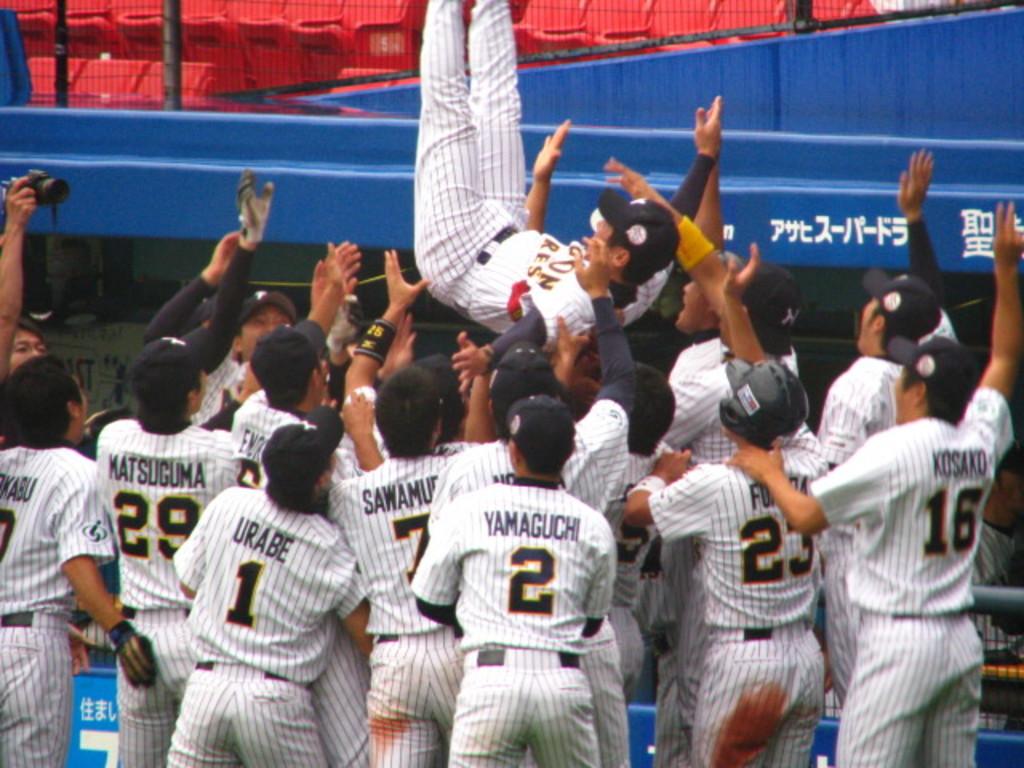Who wears the number 2 jersey?
Make the answer very short. Yamaguchi. What jersey number is sported by urabe?
Give a very brief answer. 1. 